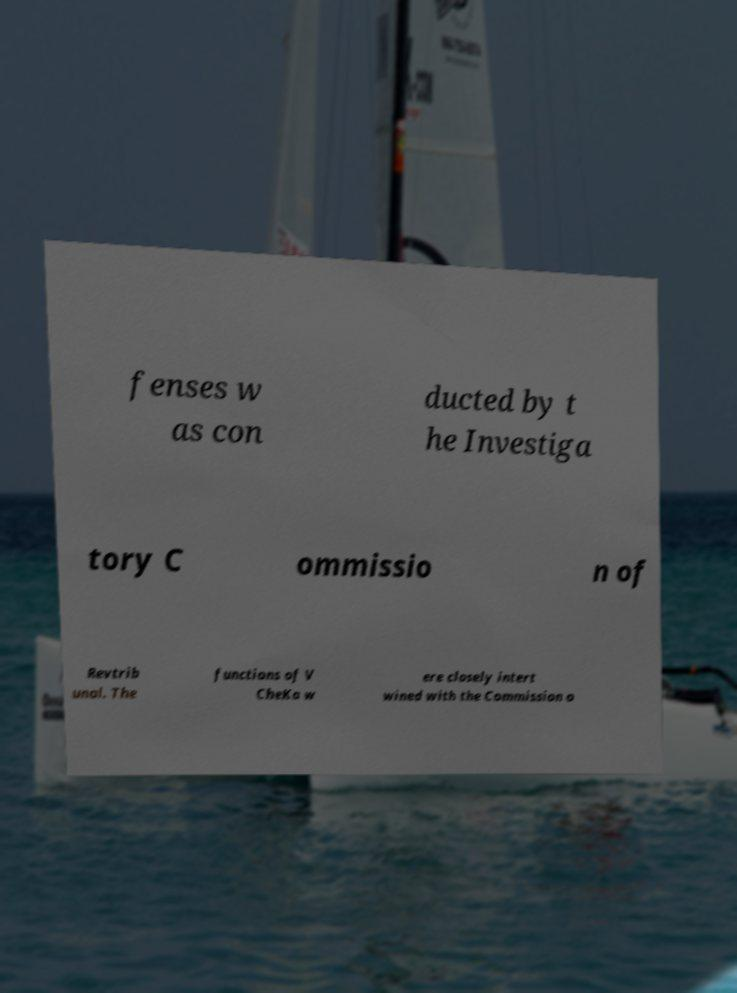Could you extract and type out the text from this image? fenses w as con ducted by t he Investiga tory C ommissio n of Revtrib unal. The functions of V CheKa w ere closely intert wined with the Commission o 